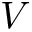<formula> <loc_0><loc_0><loc_500><loc_500>V</formula> 